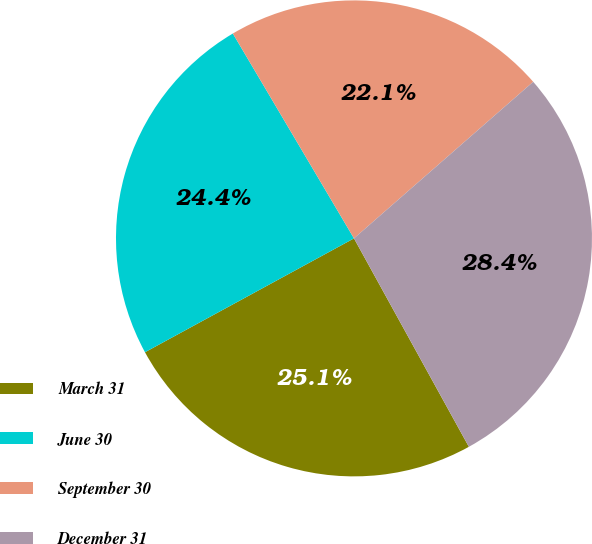Convert chart. <chart><loc_0><loc_0><loc_500><loc_500><pie_chart><fcel>March 31<fcel>June 30<fcel>September 30<fcel>December 31<nl><fcel>25.08%<fcel>24.44%<fcel>22.07%<fcel>28.41%<nl></chart> 